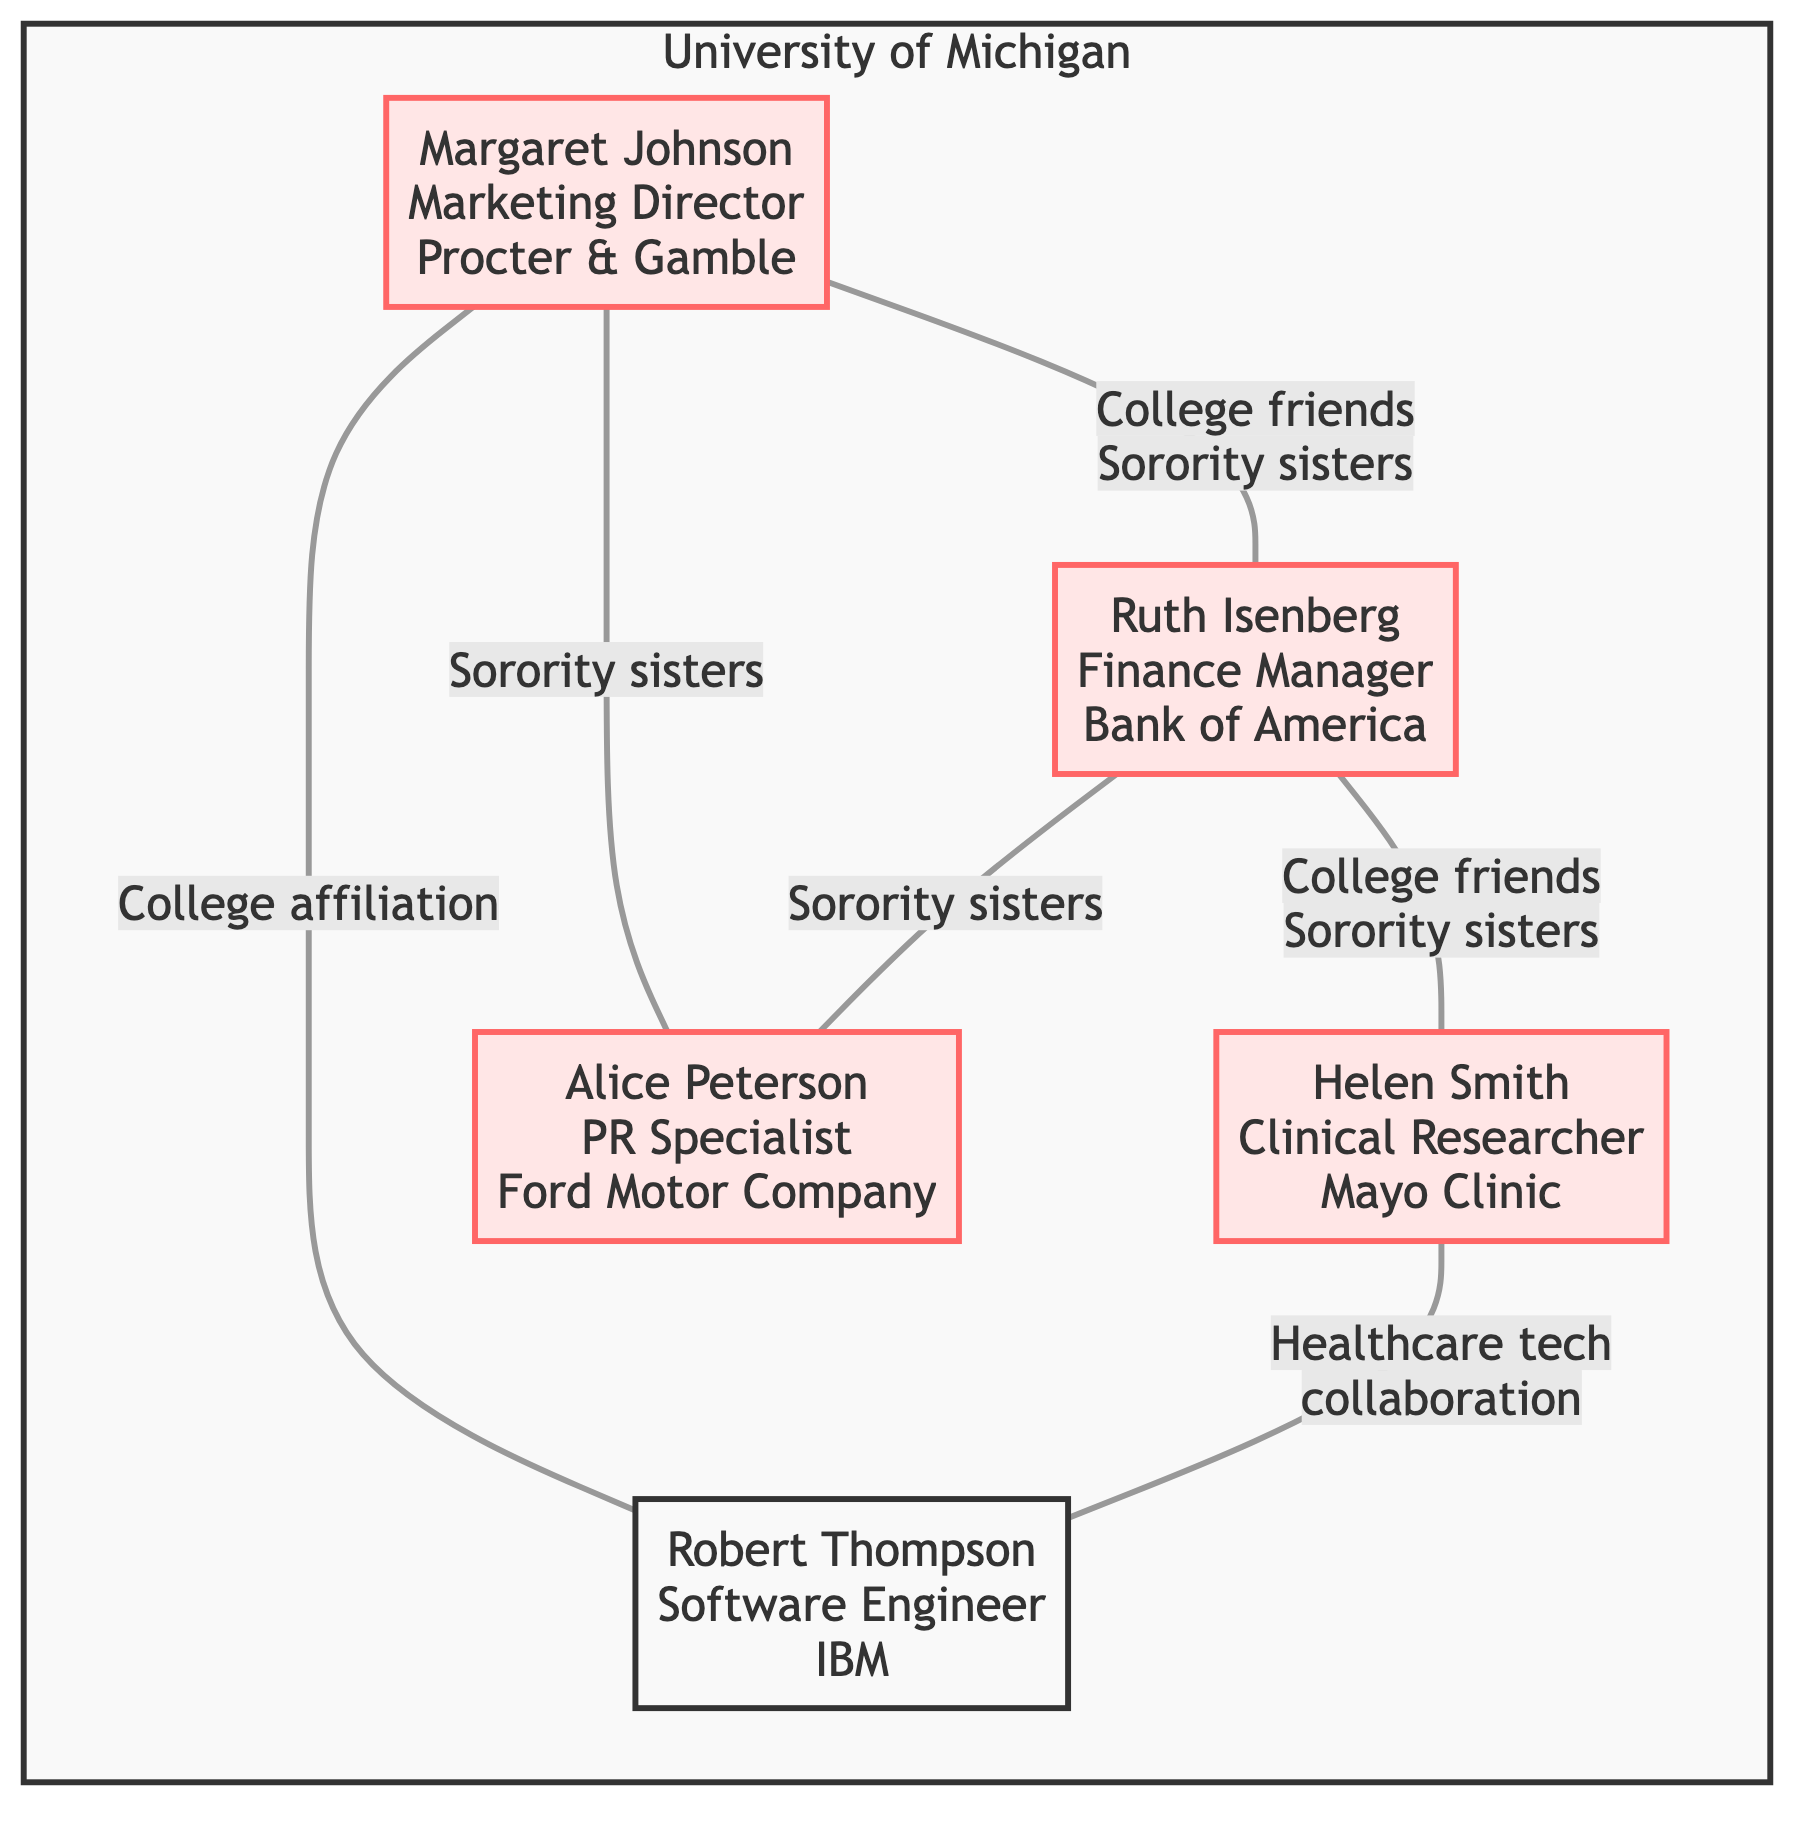What's the total number of nodes in the diagram? The diagram lists five individuals, each representing a unique node. Thus, the total number of nodes is simply the count of these individuals.
Answer: 5 What is Ruth Isenberg's role? By examining the details for Ruth Isenberg in the diagram, she is identified as the Finance Manager.
Answer: Finance Manager Which company does Margaret Johnson work for? Margaret Johnson’s entry in the diagram specifies that she is a Marketing Director at Procter & Gamble.
Answer: Procter & Gamble Who collaborates with Helen Smith on healthcare technology projects? Looking at the edges connected to Helen Smith, it is evident that she has a collaborative relationship with Robert Thompson regarding healthcare technology.
Answer: Robert Thompson What relationship connects Ruth Isenberg and Alice Peterson? The diagram indicates that Ruth Isenberg and Alice Peterson are identified as sorority sisters who coordinated financing for PR campaigns, establishing a personal and professional relationship.
Answer: Sorority sisters How many connections does Margaret Johnson have? By reviewing the edges associated with Margaret Johnson, she is connected to three individuals: Ruth Isenberg, Alice Peterson, and Robert Thompson, resulting in a total of three connections.
Answer: 3 What year was Ruth Isenberg promoted? In the career milestones listed for Ruth Isenberg, it is stated that she was promoted to Finance Manager in 1965.
Answer: 1965 Which individual started as a Research Assistant at Mayo Clinic? The information for Helen Smith specifies that she began her career there as a Research Assistant, making her the individual in question.
Answer: Helen Smith What is the common college affiliation of all sorority sisters in the network? By checking the college affiliations listed for the Kappa Kappa Gamma members, all of them attended the University of Michigan.
Answer: University of Michigan 